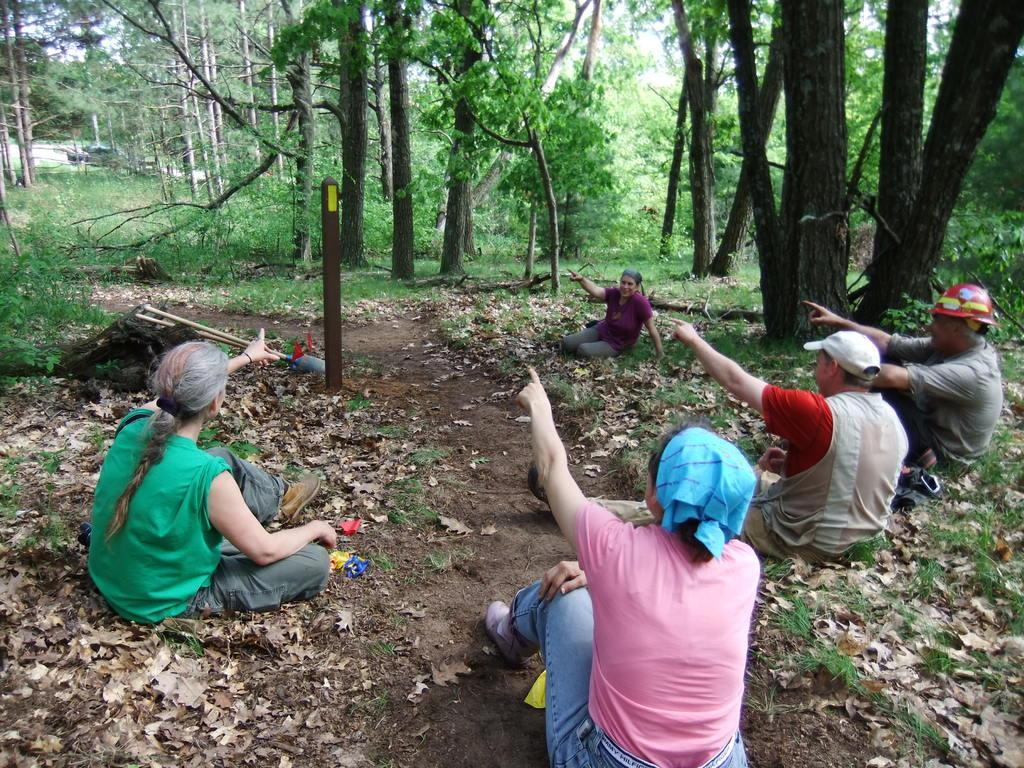What are the people in the image doing? The people in the image are sitting. What object can be seen in the image that is not a person or part of nature? There is a pole in the image. What type of ground surface is visible in the image? Grass and dried leaves are visible in the image. What type of natural elements are present in the image? Trees and plants are present in the image. What is visible at the top of the image? The sky is visible at the top of the image. How does the earthquake affect the people sitting in the image? There is no earthquake present in the image; the people are sitting calmly. What type of range can be seen in the image? There is no range present in the image; it features people sitting, a pole, grass and dried leaves, trees and plants, and the sky. 